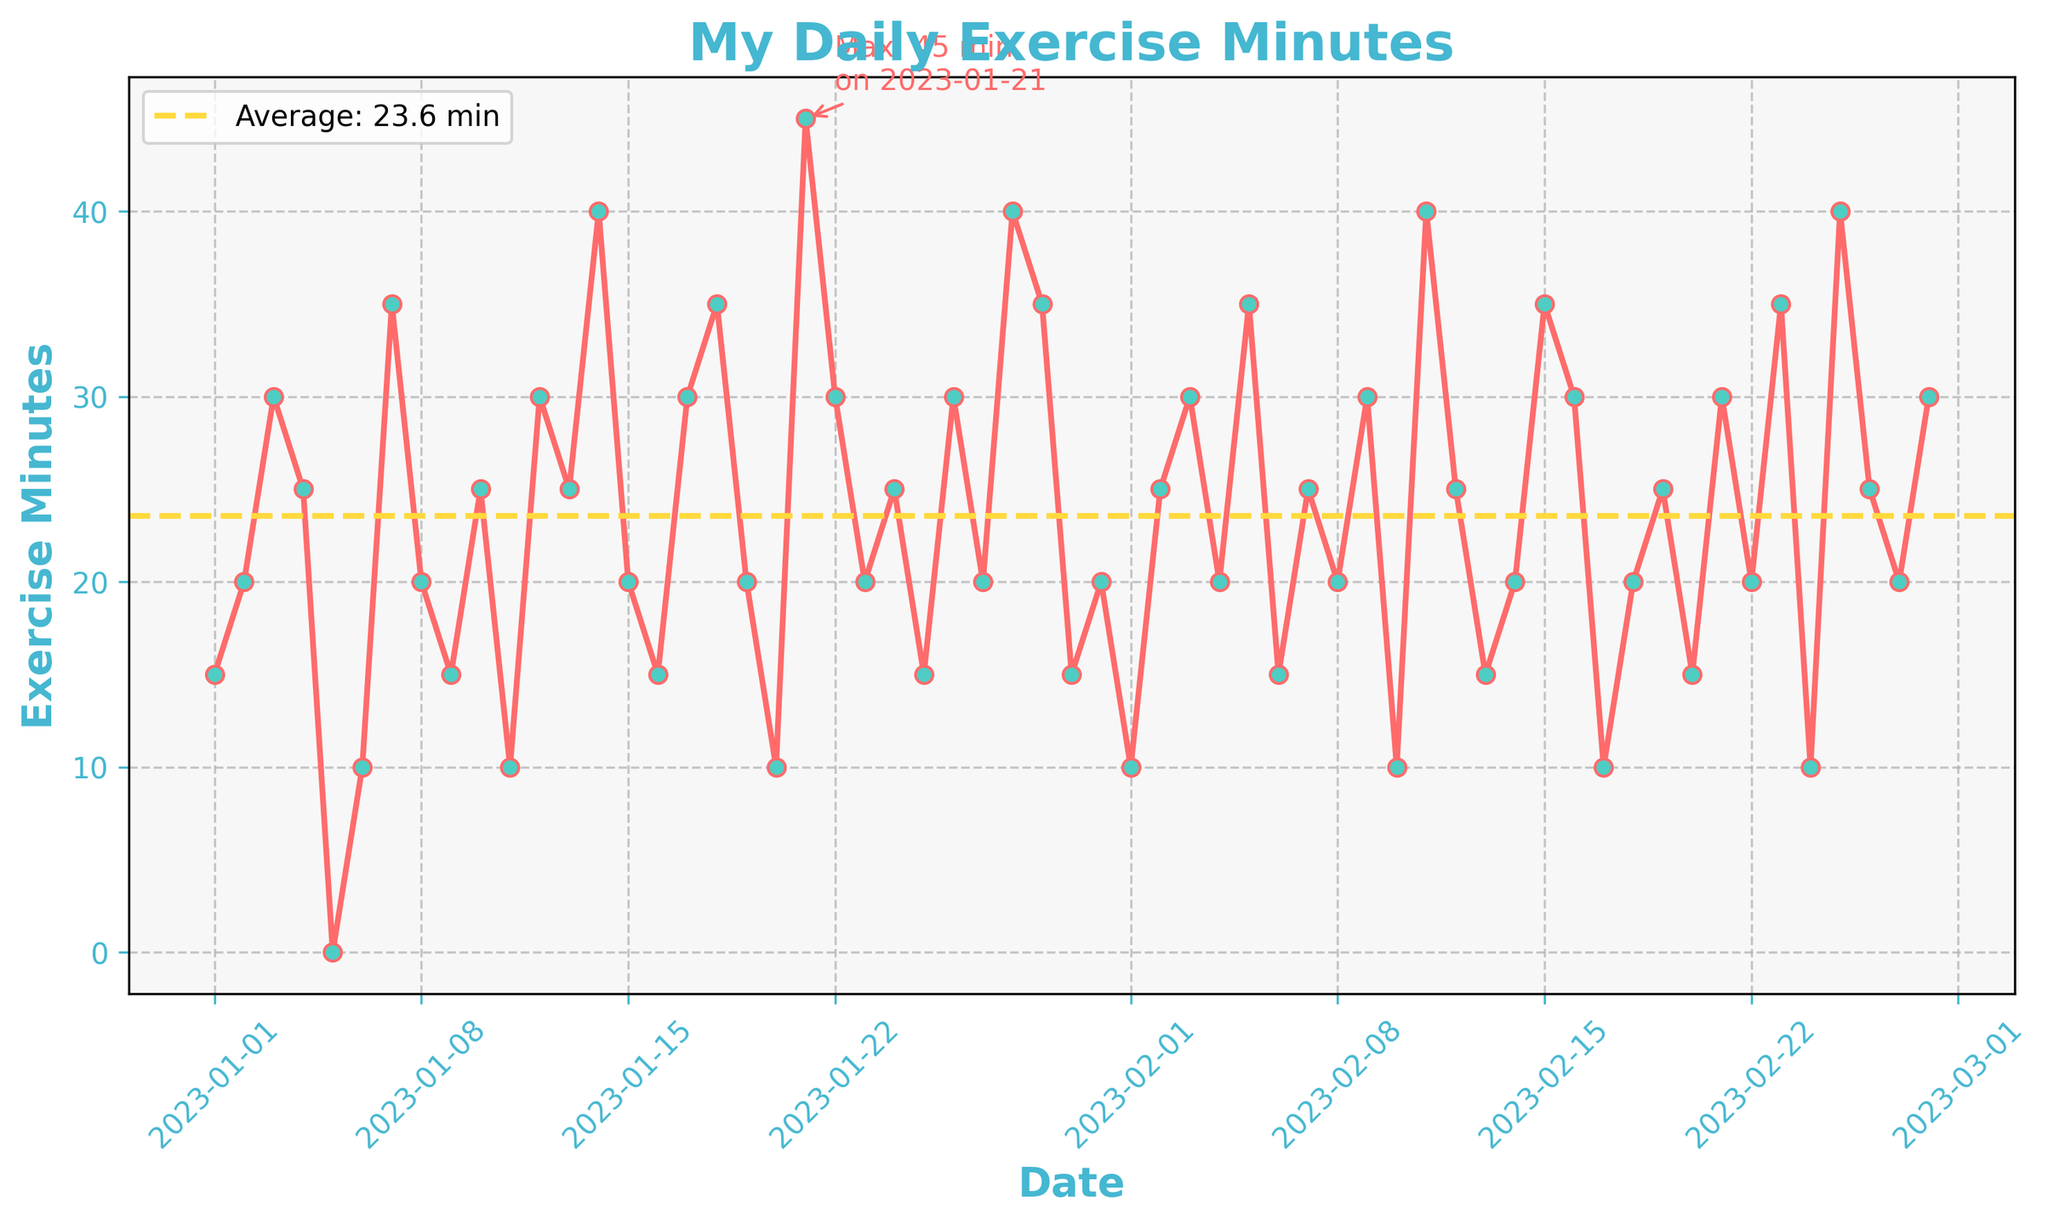What is the title of the plot? The title of the plot is usually located at the top of the figure and it describes the overall content of the plot.
Answer: My Daily Exercise Minutes What does the average exercise line represent? The average exercise line represents the mean value of exercise minutes calculated over the entire time period and is depicted as a horizontal line on the plot.
Answer: The mean value of exercise minutes Which day had the highest exercise minutes and how many minutes? To find the highest exercise minutes, look for the highest point on the plot. According to the annotation, it's also labeled.
Answer: 2023-01-21, 45 minutes What is the value of the least exercise minutes recorded, and on which day(s) did it occur? The least exercise minutes can be seen where the plot touches the lowest point, which is also annotated.
Answer: 0 minutes, on 2023-01-05 Between which dates did you have a consistent upward trend in exercise minutes for at least 3 consecutive days? Identify sections in the plot where the line continuously rises for at least three days.
Answer: 2023-01-05 to 2023-01-07 What is the color of the markers used for each data point on the plot? The color used for markers is usually set contrasting with the plot line to make them visible.
Answer: Turquoise How many times did the exercise minutes equal the average value? Count the number of times data points intersect with the average line.
Answer: 4 times How much time, on average, did you spend exercising per day during the semester? The average exercise time is indicated by the horizontal line and its value shown on the plot.
Answer: 22.9 minutes Compare the exercise minutes on the first and last days of the figure. How do they differ? Look at the plot points specifically for the first and the last dates and calculate the difference between these values.
Answer: The last day (2023-02-28) had 30 minutes, the first day (2023-01-01) had 15 minutes, so the difference is 15 minutes What is the color of the grid lines in the plot? The color of the grid lines is often made subtle, visible in the background.
Answer: Gray 